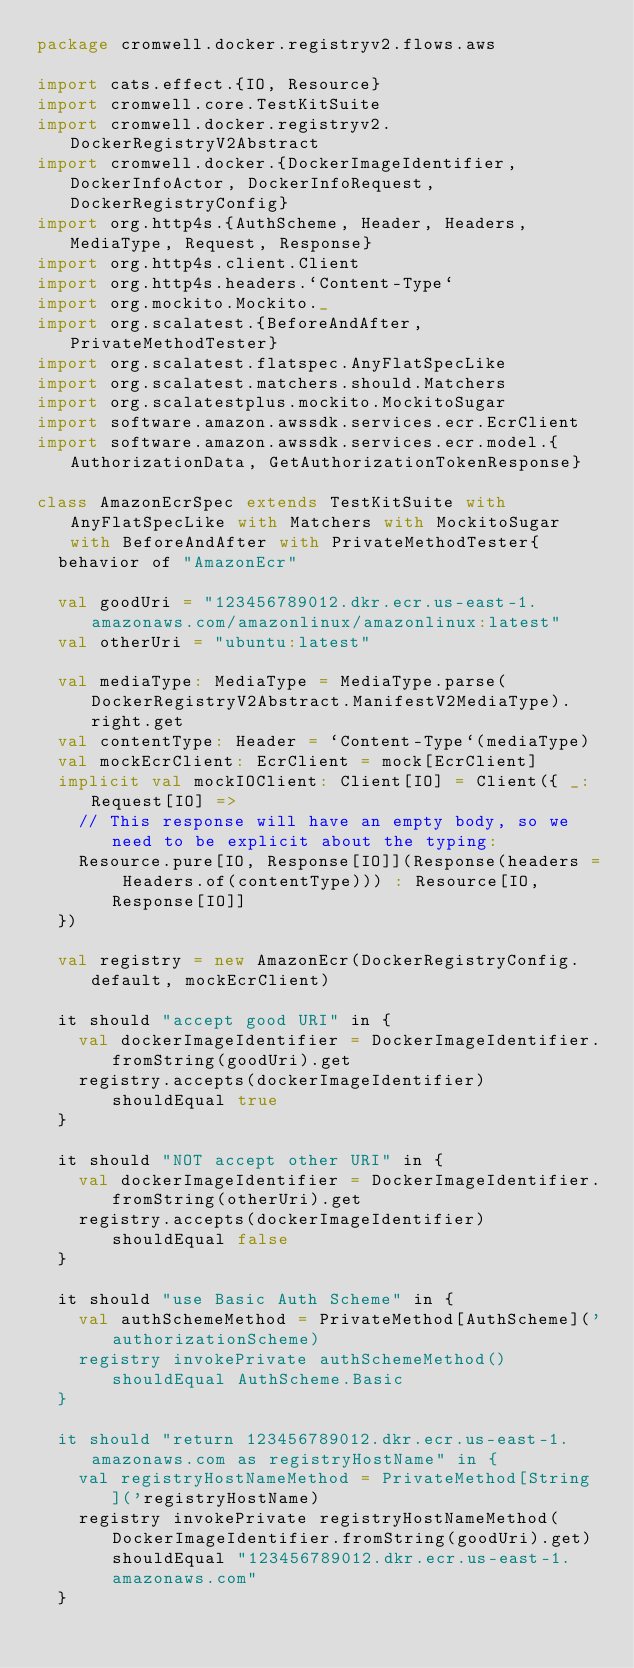<code> <loc_0><loc_0><loc_500><loc_500><_Scala_>package cromwell.docker.registryv2.flows.aws

import cats.effect.{IO, Resource}
import cromwell.core.TestKitSuite
import cromwell.docker.registryv2.DockerRegistryV2Abstract
import cromwell.docker.{DockerImageIdentifier, DockerInfoActor, DockerInfoRequest, DockerRegistryConfig}
import org.http4s.{AuthScheme, Header, Headers, MediaType, Request, Response}
import org.http4s.client.Client
import org.http4s.headers.`Content-Type`
import org.mockito.Mockito._
import org.scalatest.{BeforeAndAfter, PrivateMethodTester}
import org.scalatest.flatspec.AnyFlatSpecLike
import org.scalatest.matchers.should.Matchers
import org.scalatestplus.mockito.MockitoSugar
import software.amazon.awssdk.services.ecr.EcrClient
import software.amazon.awssdk.services.ecr.model.{AuthorizationData, GetAuthorizationTokenResponse}

class AmazonEcrSpec extends TestKitSuite with AnyFlatSpecLike with Matchers with MockitoSugar with BeforeAndAfter with PrivateMethodTester{
  behavior of "AmazonEcr"

  val goodUri = "123456789012.dkr.ecr.us-east-1.amazonaws.com/amazonlinux/amazonlinux:latest"
  val otherUri = "ubuntu:latest"

  val mediaType: MediaType = MediaType.parse(DockerRegistryV2Abstract.ManifestV2MediaType).right.get
  val contentType: Header = `Content-Type`(mediaType)
  val mockEcrClient: EcrClient = mock[EcrClient]
  implicit val mockIOClient: Client[IO] = Client({ _: Request[IO] =>
    // This response will have an empty body, so we need to be explicit about the typing:
    Resource.pure[IO, Response[IO]](Response(headers = Headers.of(contentType))) : Resource[IO, Response[IO]]
  })

  val registry = new AmazonEcr(DockerRegistryConfig.default, mockEcrClient)

  it should "accept good URI" in {
    val dockerImageIdentifier = DockerImageIdentifier.fromString(goodUri).get
    registry.accepts(dockerImageIdentifier) shouldEqual true
  }

  it should "NOT accept other URI" in {
    val dockerImageIdentifier = DockerImageIdentifier.fromString(otherUri).get
    registry.accepts(dockerImageIdentifier) shouldEqual false
  }

  it should "use Basic Auth Scheme" in {
    val authSchemeMethod = PrivateMethod[AuthScheme]('authorizationScheme)
    registry invokePrivate authSchemeMethod() shouldEqual AuthScheme.Basic
  }

  it should "return 123456789012.dkr.ecr.us-east-1.amazonaws.com as registryHostName" in {
    val registryHostNameMethod = PrivateMethod[String]('registryHostName)
    registry invokePrivate registryHostNameMethod(DockerImageIdentifier.fromString(goodUri).get) shouldEqual "123456789012.dkr.ecr.us-east-1.amazonaws.com"
  }
</code> 